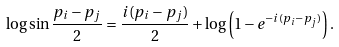<formula> <loc_0><loc_0><loc_500><loc_500>\log \sin \frac { p _ { i } - p _ { j } } { 2 } = \frac { i ( p _ { i } - p _ { j } ) } { 2 } + \log \left ( 1 - e ^ { - i ( p _ { i } - p _ { j } ) } \right ) .</formula> 